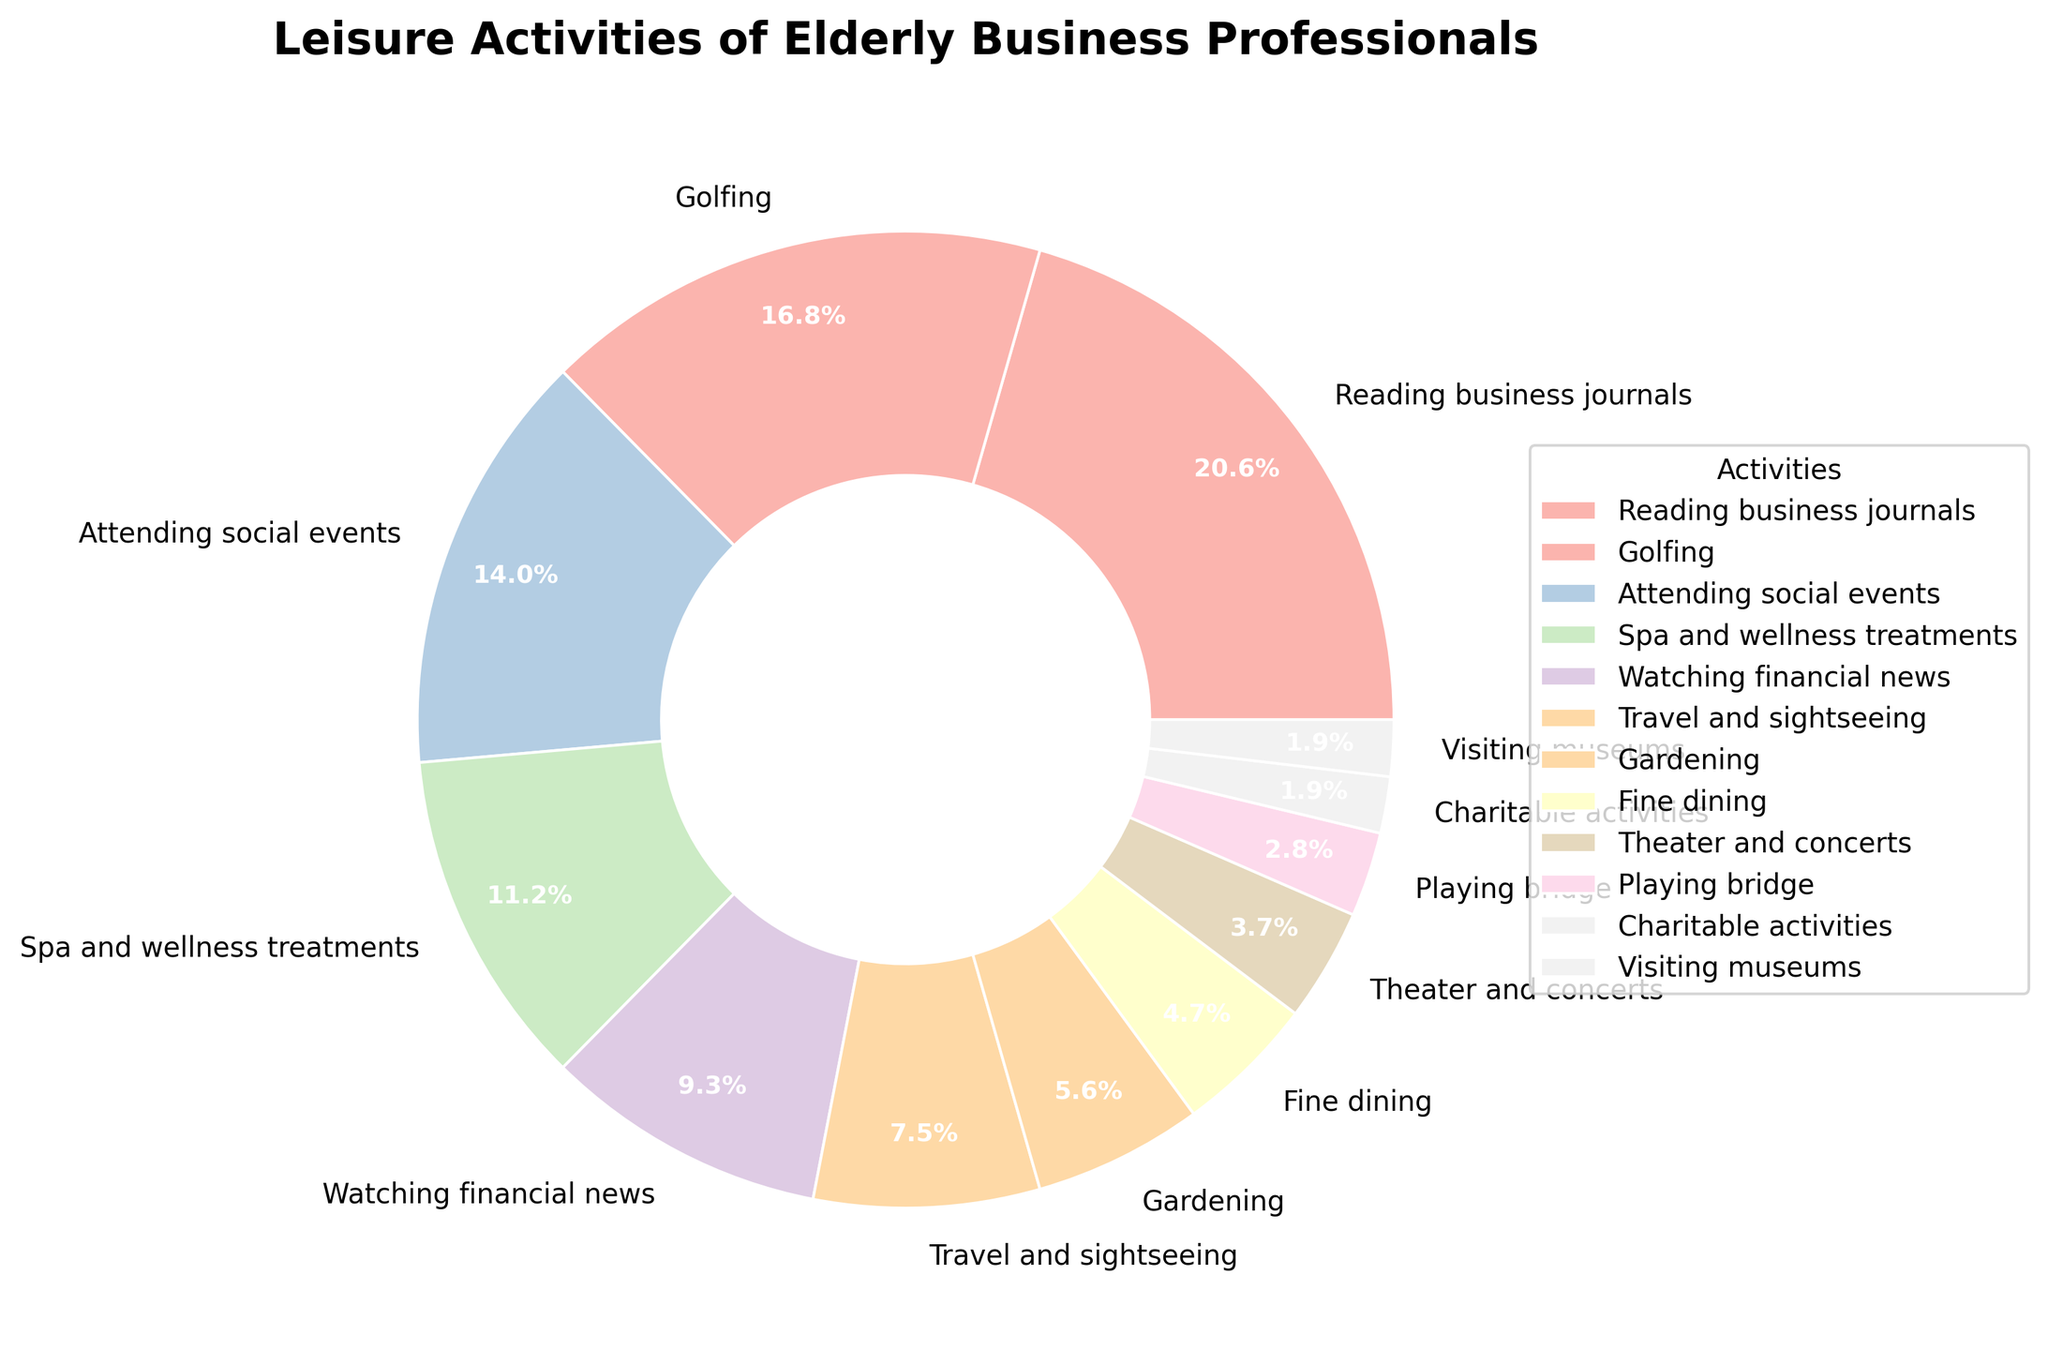Which activity has the highest percentage of participation? By looking at the pie chart, we see that 'Reading business journals' occupies the largest wedge, labeled 22%.
Answer: Reading business journals Which activities together make up more than 50% of the chart? Combining the percentages of 'Reading business journals' (22%), 'Golfing' (18%), and 'Attending social events' (15%) results in a sum of 55%.
Answer: Reading business journals, Golfing, Attending social events What is the difference in percentage between 'Watching financial news' and 'Travel and sightseeing'? 'Watching financial news' has 10%, and 'Travel and sightseeing' has 8%, so the difference is 10% - 8% = 2%.
Answer: 2% What is the sum percentage of activities related to health and wellness? 'Spa and wellness treatments' has 12%, and 'Golfing' can also be considered a health-related activity with 18%, making the total sum 12% + 18% = 30%.
Answer: 30% Which activity has the smallest participation percentage? The smallest wedge in the pie chart represents 'Charitable activities' and 'Visiting museums', each labeled 2%.
Answer: Charitable activities, Visiting museums How does 'Gardening' compare to 'Fine dining' based on their percentages? 'Gardening' has a participation of 6%, and 'Fine dining' has 5%, making 'Gardening' 1% higher than 'Fine dining'.
Answer: Gardening is 1% higher What percentage of activities fall under entertainment (like Theater and concerts or Playing bridge)? Adding the percentages of 'Theater and concerts' (4%) and 'Playing bridge' (3%) results in a total of 4% + 3% = 7%.
Answer: 7% By how much does 'Attending social events' exceed 'Watching financial news'? 'Attending social events' has 15%, and 'Watching financial news' has 10%, so the difference is 15% - 10% = 5%.
Answer: 5% What is the average percentage of the top three activities? The top three activities are 'Reading business journals' (22%), 'Golfing' (18%), and 'Attending social events' (15%). The average is (22 + 18 + 15) / 3 = 55 / 3 ≈ 18.33%.
Answer: 18.33% 